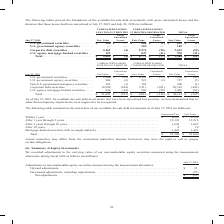According to Cisco Systems's financial document, Why would actual maturities differ from the contractual maturities? Based on the financial document, the answer is borrowers may have the right to call or prepay certain obligations.. Also, What was the amortized cost for available-for-sale debt investments  within 1 year? According to the financial document, 6,322 (in millions). The relevant text states: "� � � � � � � � � � � � � � � � � � � � � � � � $ 6,322 $ 6,324 After 1 year through 5 years � � � � � � � � � � � � � � � � � � � � � � � � � � � � � � �..." Also, What was the fair value of debt investments that had maturities after 1 year through 5 years? According to the financial document, 12,218 (in millions). The relevant text states: "� � � � � � � � � � � � � � � � � � � � � 12,191 12,218 After 5 years through 10 years � � � � � � � � � � � � � � � � � � � � � � � � � � � � � � � � � �..." Also, can you calculate: What was the fair value of debt investments that had maturities within 1 year as a percentage of the total? Based on the calculation: 6,324/21,660, the result is 29.2 (percentage). This is based on the information: "� � � � � � � � � � � � � � � � � � � $ 21,590 $ 21,660 � � � � � � � � � � � � � � � � � � � � $ 6,322 $ 6,324 After 1 year through 5 years � � � � � � � � � � � � � � � � � � � � � � � � � � � � � �..." The key data points involved are: 21,660, 6,324. Also, can you calculate: What was the difference between the amortized cost of debt investments that were within 1 year and after 1 year through 5 years? Based on the calculation: 12,191-6,322, the result is 5869 (in millions). This is based on the information: "� � � � � � � � � � � � � � � � � � � � � � � � $ 6,322 $ 6,324 After 1 year through 5 years � � � � � � � � � � � � � � � � � � � � � � � � � � � � � � � � � � � � � � � � � � � � � � � � � � � � � �..." The key data points involved are: 12,191, 6,322. Also, can you calculate: What was the difference between the total amortized cost and total fair value? Based on the calculation: 21,660-21,590, the result is 70 (in millions). This is based on the information: "� � � � � � � � � � � � � � � � � � � $ 21,590 $ 21,660 � � � � � � � � � � � � � � � � � � � � � � � � $ 21,590 $ 21,660..." The key data points involved are: 21,590, 21,660. 